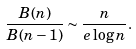Convert formula to latex. <formula><loc_0><loc_0><loc_500><loc_500>\frac { B ( n ) } { B ( n - 1 ) } \sim \frac { n } { e \log n } .</formula> 